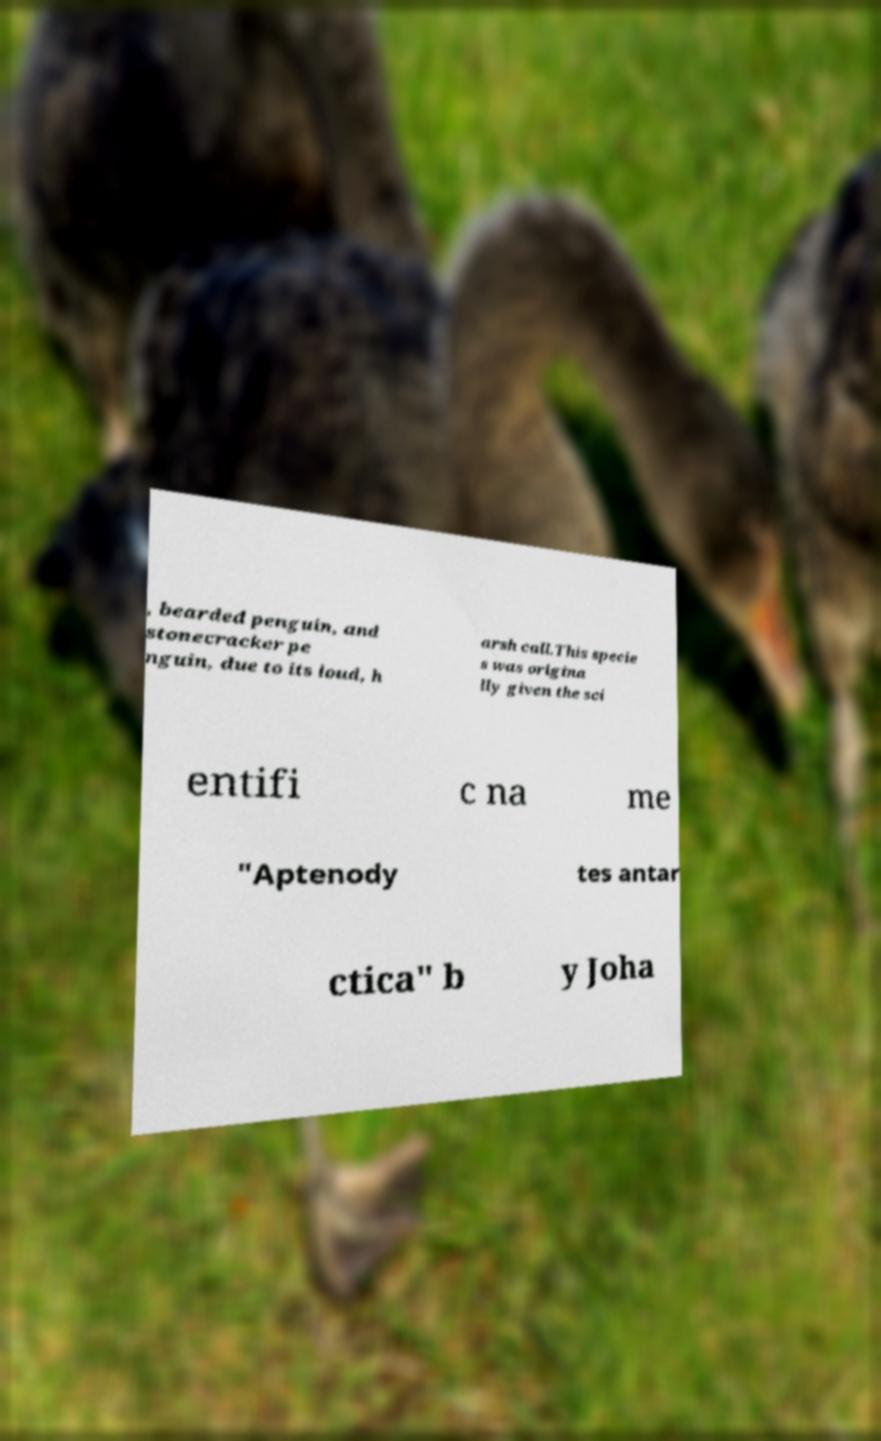There's text embedded in this image that I need extracted. Can you transcribe it verbatim? , bearded penguin, and stonecracker pe nguin, due to its loud, h arsh call.This specie s was origina lly given the sci entifi c na me "Aptenody tes antar ctica" b y Joha 